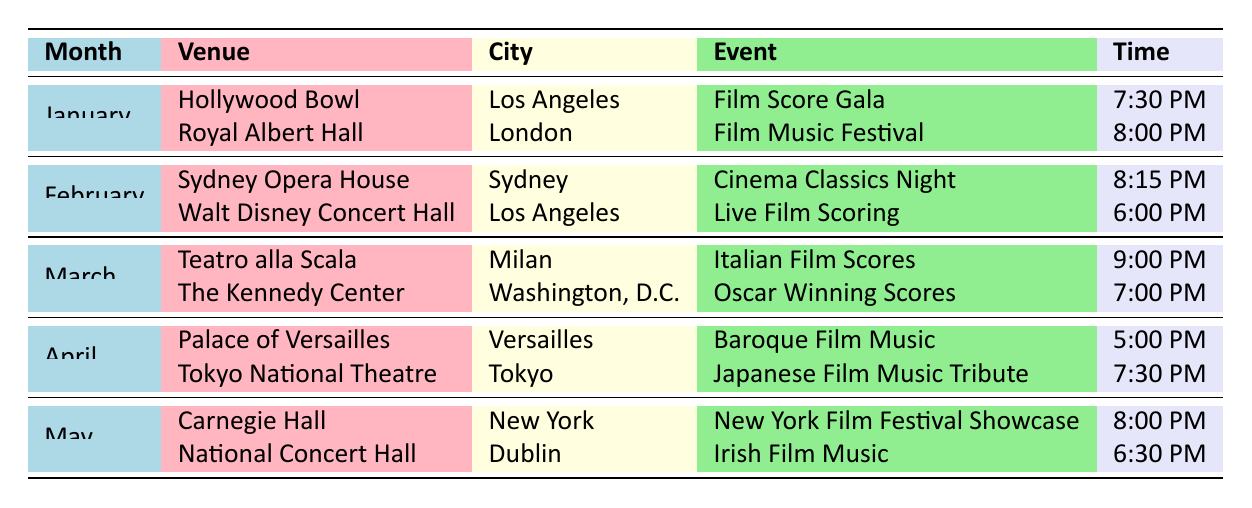What events are scheduled for January? The table lists two events scheduled in January: "Film Score Gala" at Hollywood Bowl in Los Angeles at 7:30 PM and "Film Music Festival" at Royal Albert Hall in London at 8:00 PM.
Answer: Film Score Gala, Film Music Festival Which venue is hosting the event in Sydney in February? According to the table, the venue in Sydney for February is the Sydney Opera House, which is hosting the "Cinema Classics Night" at 8:15 PM.
Answer: Sydney Opera House Is there an event scheduled in Dublin during May? The table shows one event scheduled in May at the National Concert Hall in Dublin, titled "Irish Film Music" at 6:30 PM, confirming that there is indeed an event in Dublin.
Answer: Yes What is the time for the "Japanese Film Music Tribute" in April? The table indicates that the "Japanese Film Music Tribute" is being held at the Tokyo National Theatre in Tokyo at 7:30 PM during April.
Answer: 7:30 PM How many locations are listed for the performance schedules in March? The table details two performances in March, one at Teatro alla Scala in Milan and another at The Kennedy Center in Washington, D.C. Therefore, the total number of locations is two.
Answer: 2 Which month has the earliest scheduled concert time, and what is that time? By examining the times in the table, the earliest concert time listed is 5:00 PM for "Baroque Film Music" at the Palace of Versailles in April. April has the earliest scheduled concert time at 5:00 PM.
Answer: April, 5:00 PM Are there any performances scheduled at Carnegie Hall? The table indicates that there is a performance scheduled at Carnegie Hall in New York during May for the "New York Film Festival Showcase," confirming that there is indeed a performance at that venue.
Answer: Yes What is the event taking place in Milan in March, and what time does it start? Looking at the table, the event scheduled in Milan during March is "Italian Film Scores" at Teatro alla Scala, starting at 9:00 PM.
Answer: Italian Film Scores, 9:00 PM Which city is hosting the "Oscars Winning Scores" event? The table shows that the "Oscar Winning Scores" event is being hosted at The Kennedy Center, located in Washington, D.C.
Answer: Washington, D.C 